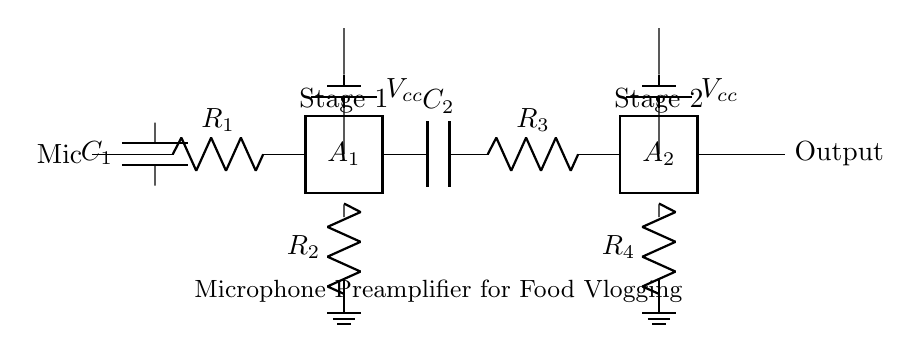What is the type of the first amplifier? The first amplifier is a two-port amplifier designated as A1, which indicates that it has two input/output terminals for signal processing.
Answer: two-port How many resistors are present in the circuit? By counting the components in the circuit diagram, we see two resistors R1 and R2 for the first stage, and two resistors R3 and R4 for the second stage, which adds up to a total of four resistors.
Answer: four What is the role of C1 in this circuit? C1 is a coupling capacitor that primarily functions to block any DC component while allowing the AC audio signal from the microphone to pass to the amplifier.
Answer: coupling What is the purpose of the output in this microphone preamplifier? The output in the circuit diagram is where the amplified audio signal, after being processed by both amplifier stages, can be sent to other devices like audio interfaces or recording equipment for further use.
Answer: amplification What is the voltage supply for each amplifier stage? Both amplifier stages are powered by a DC voltage supply labeled as Vcc, indicating each stage receives a separate power supply for proper operation.
Answer: Vcc Which component is connected to the ground in the first stage? In the first amplifier stage, R2 is connected to ground, providing a reference point for the circuit and allowing the return path for the signal.
Answer: R2 What is the function of the second coupling capacitor, C2? C2 allows the amplified audio signal from the first amplifier stage to pass to the second amplifier stage while blocking any DC component from affecting the second stage's operation.
Answer: coupling 